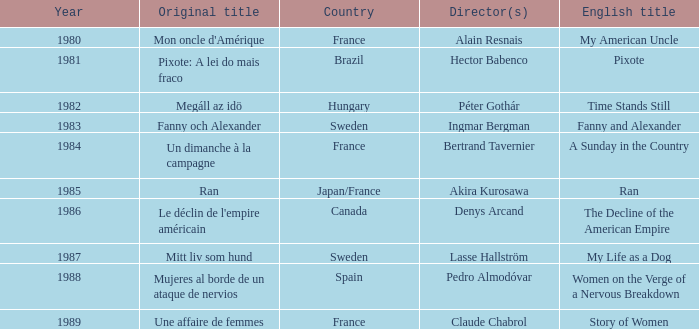What's the English Title of Fanny Och Alexander? Fanny and Alexander. 